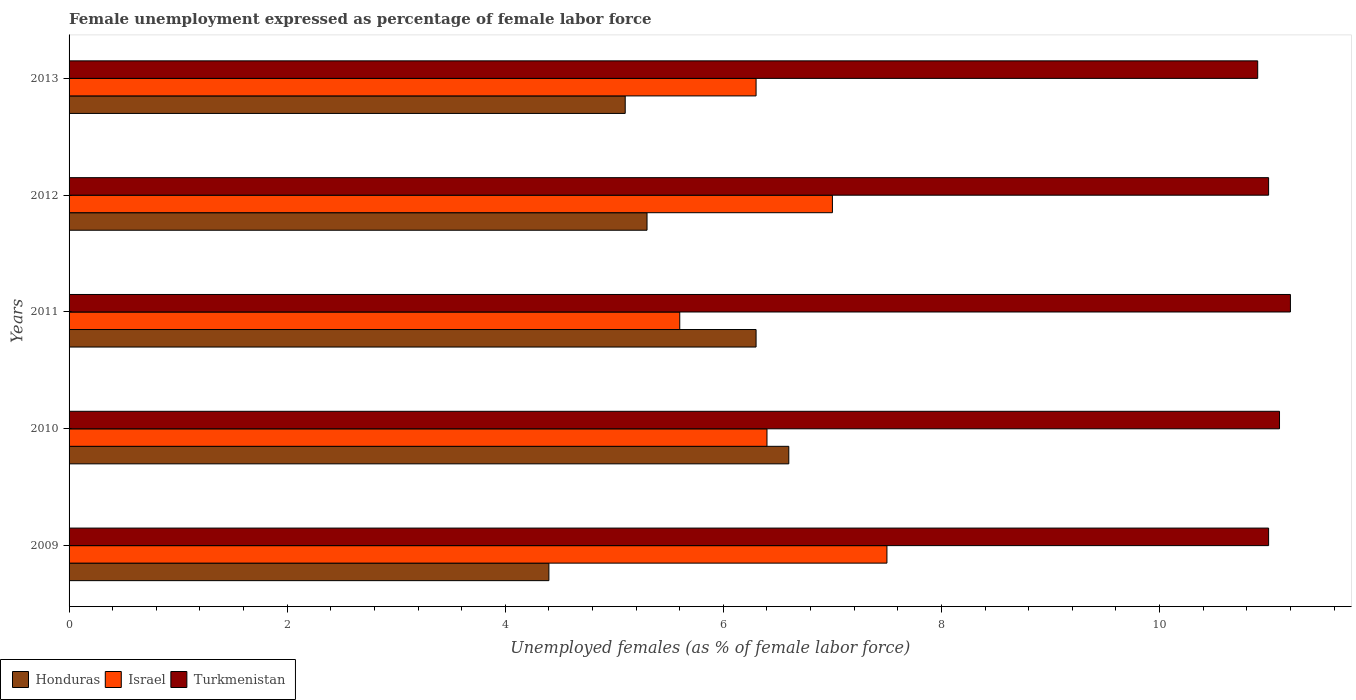How many groups of bars are there?
Provide a succinct answer. 5. Are the number of bars per tick equal to the number of legend labels?
Ensure brevity in your answer.  Yes. How many bars are there on the 4th tick from the bottom?
Keep it short and to the point. 3. What is the unemployment in females in in Israel in 2010?
Your answer should be compact. 6.4. Across all years, what is the maximum unemployment in females in in Israel?
Ensure brevity in your answer.  7.5. Across all years, what is the minimum unemployment in females in in Turkmenistan?
Provide a short and direct response. 10.9. In which year was the unemployment in females in in Turkmenistan maximum?
Make the answer very short. 2011. What is the total unemployment in females in in Israel in the graph?
Your answer should be compact. 32.8. What is the difference between the unemployment in females in in Turkmenistan in 2009 and that in 2013?
Offer a very short reply. 0.1. What is the difference between the unemployment in females in in Honduras in 2009 and the unemployment in females in in Israel in 2011?
Keep it short and to the point. -1.2. What is the average unemployment in females in in Israel per year?
Make the answer very short. 6.56. In the year 2011, what is the difference between the unemployment in females in in Israel and unemployment in females in in Honduras?
Your answer should be compact. -0.7. In how many years, is the unemployment in females in in Turkmenistan greater than 6 %?
Your answer should be compact. 5. What is the ratio of the unemployment in females in in Honduras in 2009 to that in 2010?
Your answer should be compact. 0.67. Is the unemployment in females in in Honduras in 2010 less than that in 2012?
Offer a very short reply. No. Is the difference between the unemployment in females in in Israel in 2010 and 2013 greater than the difference between the unemployment in females in in Honduras in 2010 and 2013?
Keep it short and to the point. No. What is the difference between the highest and the second highest unemployment in females in in Israel?
Your response must be concise. 0.5. What is the difference between the highest and the lowest unemployment in females in in Honduras?
Give a very brief answer. 2.2. In how many years, is the unemployment in females in in Turkmenistan greater than the average unemployment in females in in Turkmenistan taken over all years?
Give a very brief answer. 2. Is the sum of the unemployment in females in in Israel in 2009 and 2012 greater than the maximum unemployment in females in in Honduras across all years?
Offer a terse response. Yes. What does the 2nd bar from the top in 2012 represents?
Make the answer very short. Israel. What does the 3rd bar from the bottom in 2011 represents?
Keep it short and to the point. Turkmenistan. Is it the case that in every year, the sum of the unemployment in females in in Israel and unemployment in females in in Honduras is greater than the unemployment in females in in Turkmenistan?
Make the answer very short. Yes. Are the values on the major ticks of X-axis written in scientific E-notation?
Your answer should be very brief. No. Does the graph contain any zero values?
Provide a short and direct response. No. Does the graph contain grids?
Keep it short and to the point. No. How many legend labels are there?
Make the answer very short. 3. How are the legend labels stacked?
Offer a terse response. Horizontal. What is the title of the graph?
Your answer should be very brief. Female unemployment expressed as percentage of female labor force. Does "New Zealand" appear as one of the legend labels in the graph?
Make the answer very short. No. What is the label or title of the X-axis?
Offer a terse response. Unemployed females (as % of female labor force). What is the Unemployed females (as % of female labor force) in Honduras in 2009?
Offer a terse response. 4.4. What is the Unemployed females (as % of female labor force) of Honduras in 2010?
Offer a very short reply. 6.6. What is the Unemployed females (as % of female labor force) of Israel in 2010?
Ensure brevity in your answer.  6.4. What is the Unemployed females (as % of female labor force) in Turkmenistan in 2010?
Your answer should be very brief. 11.1. What is the Unemployed females (as % of female labor force) of Honduras in 2011?
Offer a terse response. 6.3. What is the Unemployed females (as % of female labor force) in Israel in 2011?
Make the answer very short. 5.6. What is the Unemployed females (as % of female labor force) of Turkmenistan in 2011?
Provide a short and direct response. 11.2. What is the Unemployed females (as % of female labor force) in Honduras in 2012?
Give a very brief answer. 5.3. What is the Unemployed females (as % of female labor force) in Israel in 2012?
Ensure brevity in your answer.  7. What is the Unemployed females (as % of female labor force) of Honduras in 2013?
Keep it short and to the point. 5.1. What is the Unemployed females (as % of female labor force) of Israel in 2013?
Offer a terse response. 6.3. What is the Unemployed females (as % of female labor force) of Turkmenistan in 2013?
Your answer should be compact. 10.9. Across all years, what is the maximum Unemployed females (as % of female labor force) in Honduras?
Offer a very short reply. 6.6. Across all years, what is the maximum Unemployed females (as % of female labor force) of Turkmenistan?
Your answer should be compact. 11.2. Across all years, what is the minimum Unemployed females (as % of female labor force) of Honduras?
Offer a very short reply. 4.4. Across all years, what is the minimum Unemployed females (as % of female labor force) of Israel?
Give a very brief answer. 5.6. Across all years, what is the minimum Unemployed females (as % of female labor force) of Turkmenistan?
Offer a terse response. 10.9. What is the total Unemployed females (as % of female labor force) of Honduras in the graph?
Your response must be concise. 27.7. What is the total Unemployed females (as % of female labor force) in Israel in the graph?
Provide a short and direct response. 32.8. What is the total Unemployed females (as % of female labor force) in Turkmenistan in the graph?
Offer a terse response. 55.2. What is the difference between the Unemployed females (as % of female labor force) of Honduras in 2009 and that in 2010?
Make the answer very short. -2.2. What is the difference between the Unemployed females (as % of female labor force) in Israel in 2009 and that in 2010?
Your answer should be very brief. 1.1. What is the difference between the Unemployed females (as % of female labor force) of Honduras in 2009 and that in 2012?
Give a very brief answer. -0.9. What is the difference between the Unemployed females (as % of female labor force) of Israel in 2009 and that in 2012?
Give a very brief answer. 0.5. What is the difference between the Unemployed females (as % of female labor force) of Honduras in 2009 and that in 2013?
Offer a terse response. -0.7. What is the difference between the Unemployed females (as % of female labor force) in Israel in 2009 and that in 2013?
Your answer should be compact. 1.2. What is the difference between the Unemployed females (as % of female labor force) in Israel in 2010 and that in 2011?
Give a very brief answer. 0.8. What is the difference between the Unemployed females (as % of female labor force) of Turkmenistan in 2010 and that in 2011?
Your answer should be very brief. -0.1. What is the difference between the Unemployed females (as % of female labor force) in Honduras in 2010 and that in 2012?
Your answer should be compact. 1.3. What is the difference between the Unemployed females (as % of female labor force) in Turkmenistan in 2010 and that in 2012?
Offer a very short reply. 0.1. What is the difference between the Unemployed females (as % of female labor force) in Israel in 2010 and that in 2013?
Offer a very short reply. 0.1. What is the difference between the Unemployed females (as % of female labor force) of Turkmenistan in 2010 and that in 2013?
Provide a succinct answer. 0.2. What is the difference between the Unemployed females (as % of female labor force) of Israel in 2011 and that in 2012?
Offer a very short reply. -1.4. What is the difference between the Unemployed females (as % of female labor force) in Turkmenistan in 2011 and that in 2012?
Offer a terse response. 0.2. What is the difference between the Unemployed females (as % of female labor force) in Israel in 2011 and that in 2013?
Make the answer very short. -0.7. What is the difference between the Unemployed females (as % of female labor force) in Israel in 2012 and that in 2013?
Make the answer very short. 0.7. What is the difference between the Unemployed females (as % of female labor force) of Turkmenistan in 2012 and that in 2013?
Offer a terse response. 0.1. What is the difference between the Unemployed females (as % of female labor force) of Honduras in 2009 and the Unemployed females (as % of female labor force) of Israel in 2010?
Ensure brevity in your answer.  -2. What is the difference between the Unemployed females (as % of female labor force) in Honduras in 2009 and the Unemployed females (as % of female labor force) in Israel in 2011?
Ensure brevity in your answer.  -1.2. What is the difference between the Unemployed females (as % of female labor force) of Honduras in 2009 and the Unemployed females (as % of female labor force) of Turkmenistan in 2011?
Your answer should be very brief. -6.8. What is the difference between the Unemployed females (as % of female labor force) of Israel in 2009 and the Unemployed females (as % of female labor force) of Turkmenistan in 2011?
Provide a succinct answer. -3.7. What is the difference between the Unemployed females (as % of female labor force) of Honduras in 2009 and the Unemployed females (as % of female labor force) of Turkmenistan in 2012?
Your answer should be very brief. -6.6. What is the difference between the Unemployed females (as % of female labor force) in Israel in 2009 and the Unemployed females (as % of female labor force) in Turkmenistan in 2012?
Your answer should be very brief. -3.5. What is the difference between the Unemployed females (as % of female labor force) of Honduras in 2009 and the Unemployed females (as % of female labor force) of Turkmenistan in 2013?
Provide a succinct answer. -6.5. What is the difference between the Unemployed females (as % of female labor force) in Honduras in 2010 and the Unemployed females (as % of female labor force) in Israel in 2011?
Provide a short and direct response. 1. What is the difference between the Unemployed females (as % of female labor force) in Honduras in 2010 and the Unemployed females (as % of female labor force) in Turkmenistan in 2011?
Keep it short and to the point. -4.6. What is the difference between the Unemployed females (as % of female labor force) of Israel in 2010 and the Unemployed females (as % of female labor force) of Turkmenistan in 2011?
Your response must be concise. -4.8. What is the difference between the Unemployed females (as % of female labor force) of Honduras in 2010 and the Unemployed females (as % of female labor force) of Israel in 2012?
Provide a short and direct response. -0.4. What is the difference between the Unemployed females (as % of female labor force) in Israel in 2010 and the Unemployed females (as % of female labor force) in Turkmenistan in 2013?
Provide a succinct answer. -4.5. What is the difference between the Unemployed females (as % of female labor force) in Honduras in 2011 and the Unemployed females (as % of female labor force) in Israel in 2012?
Offer a terse response. -0.7. What is the difference between the Unemployed females (as % of female labor force) in Honduras in 2011 and the Unemployed females (as % of female labor force) in Turkmenistan in 2012?
Offer a terse response. -4.7. What is the difference between the Unemployed females (as % of female labor force) of Israel in 2011 and the Unemployed females (as % of female labor force) of Turkmenistan in 2012?
Your response must be concise. -5.4. What is the difference between the Unemployed females (as % of female labor force) in Honduras in 2011 and the Unemployed females (as % of female labor force) in Israel in 2013?
Your answer should be compact. 0. What is the difference between the Unemployed females (as % of female labor force) of Honduras in 2011 and the Unemployed females (as % of female labor force) of Turkmenistan in 2013?
Your response must be concise. -4.6. What is the difference between the Unemployed females (as % of female labor force) in Israel in 2011 and the Unemployed females (as % of female labor force) in Turkmenistan in 2013?
Ensure brevity in your answer.  -5.3. What is the difference between the Unemployed females (as % of female labor force) in Honduras in 2012 and the Unemployed females (as % of female labor force) in Israel in 2013?
Make the answer very short. -1. What is the difference between the Unemployed females (as % of female labor force) in Honduras in 2012 and the Unemployed females (as % of female labor force) in Turkmenistan in 2013?
Give a very brief answer. -5.6. What is the difference between the Unemployed females (as % of female labor force) in Israel in 2012 and the Unemployed females (as % of female labor force) in Turkmenistan in 2013?
Offer a very short reply. -3.9. What is the average Unemployed females (as % of female labor force) of Honduras per year?
Give a very brief answer. 5.54. What is the average Unemployed females (as % of female labor force) of Israel per year?
Your answer should be compact. 6.56. What is the average Unemployed females (as % of female labor force) of Turkmenistan per year?
Offer a very short reply. 11.04. In the year 2009, what is the difference between the Unemployed females (as % of female labor force) in Honduras and Unemployed females (as % of female labor force) in Israel?
Provide a succinct answer. -3.1. In the year 2009, what is the difference between the Unemployed females (as % of female labor force) in Israel and Unemployed females (as % of female labor force) in Turkmenistan?
Make the answer very short. -3.5. In the year 2010, what is the difference between the Unemployed females (as % of female labor force) in Honduras and Unemployed females (as % of female labor force) in Israel?
Provide a succinct answer. 0.2. In the year 2011, what is the difference between the Unemployed females (as % of female labor force) of Honduras and Unemployed females (as % of female labor force) of Israel?
Keep it short and to the point. 0.7. In the year 2012, what is the difference between the Unemployed females (as % of female labor force) of Honduras and Unemployed females (as % of female labor force) of Israel?
Make the answer very short. -1.7. In the year 2012, what is the difference between the Unemployed females (as % of female labor force) of Honduras and Unemployed females (as % of female labor force) of Turkmenistan?
Your answer should be compact. -5.7. In the year 2013, what is the difference between the Unemployed females (as % of female labor force) of Honduras and Unemployed females (as % of female labor force) of Israel?
Provide a short and direct response. -1.2. What is the ratio of the Unemployed females (as % of female labor force) of Israel in 2009 to that in 2010?
Your answer should be compact. 1.17. What is the ratio of the Unemployed females (as % of female labor force) in Honduras in 2009 to that in 2011?
Make the answer very short. 0.7. What is the ratio of the Unemployed females (as % of female labor force) of Israel in 2009 to that in 2011?
Give a very brief answer. 1.34. What is the ratio of the Unemployed females (as % of female labor force) of Turkmenistan in 2009 to that in 2011?
Offer a very short reply. 0.98. What is the ratio of the Unemployed females (as % of female labor force) of Honduras in 2009 to that in 2012?
Provide a short and direct response. 0.83. What is the ratio of the Unemployed females (as % of female labor force) of Israel in 2009 to that in 2012?
Keep it short and to the point. 1.07. What is the ratio of the Unemployed females (as % of female labor force) of Honduras in 2009 to that in 2013?
Offer a very short reply. 0.86. What is the ratio of the Unemployed females (as % of female labor force) of Israel in 2009 to that in 2013?
Give a very brief answer. 1.19. What is the ratio of the Unemployed females (as % of female labor force) of Turkmenistan in 2009 to that in 2013?
Make the answer very short. 1.01. What is the ratio of the Unemployed females (as % of female labor force) of Honduras in 2010 to that in 2011?
Your answer should be compact. 1.05. What is the ratio of the Unemployed females (as % of female labor force) of Israel in 2010 to that in 2011?
Offer a terse response. 1.14. What is the ratio of the Unemployed females (as % of female labor force) in Honduras in 2010 to that in 2012?
Offer a very short reply. 1.25. What is the ratio of the Unemployed females (as % of female labor force) of Israel in 2010 to that in 2012?
Offer a very short reply. 0.91. What is the ratio of the Unemployed females (as % of female labor force) in Turkmenistan in 2010 to that in 2012?
Provide a short and direct response. 1.01. What is the ratio of the Unemployed females (as % of female labor force) in Honduras in 2010 to that in 2013?
Provide a short and direct response. 1.29. What is the ratio of the Unemployed females (as % of female labor force) in Israel in 2010 to that in 2013?
Provide a short and direct response. 1.02. What is the ratio of the Unemployed females (as % of female labor force) in Turkmenistan in 2010 to that in 2013?
Offer a terse response. 1.02. What is the ratio of the Unemployed females (as % of female labor force) in Honduras in 2011 to that in 2012?
Keep it short and to the point. 1.19. What is the ratio of the Unemployed females (as % of female labor force) in Israel in 2011 to that in 2012?
Ensure brevity in your answer.  0.8. What is the ratio of the Unemployed females (as % of female labor force) in Turkmenistan in 2011 to that in 2012?
Offer a terse response. 1.02. What is the ratio of the Unemployed females (as % of female labor force) of Honduras in 2011 to that in 2013?
Offer a very short reply. 1.24. What is the ratio of the Unemployed females (as % of female labor force) of Israel in 2011 to that in 2013?
Offer a terse response. 0.89. What is the ratio of the Unemployed females (as % of female labor force) in Turkmenistan in 2011 to that in 2013?
Make the answer very short. 1.03. What is the ratio of the Unemployed females (as % of female labor force) of Honduras in 2012 to that in 2013?
Offer a very short reply. 1.04. What is the ratio of the Unemployed females (as % of female labor force) of Turkmenistan in 2012 to that in 2013?
Ensure brevity in your answer.  1.01. What is the difference between the highest and the second highest Unemployed females (as % of female labor force) in Honduras?
Your response must be concise. 0.3. 